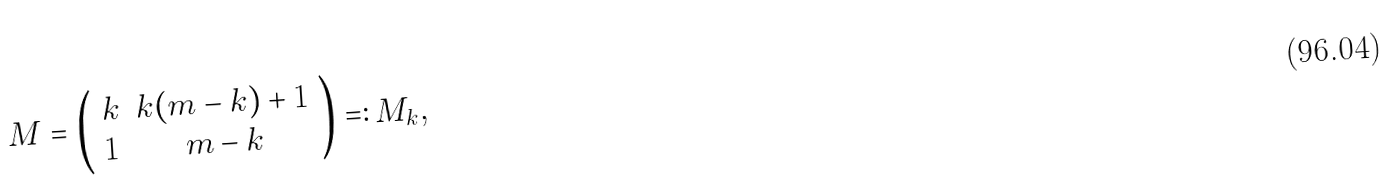Convert formula to latex. <formula><loc_0><loc_0><loc_500><loc_500>M = \left ( \begin{array} { l c } k & k ( m - k ) + 1 \\ 1 & m - k \end{array} \right ) = \colon M _ { k } ,</formula> 